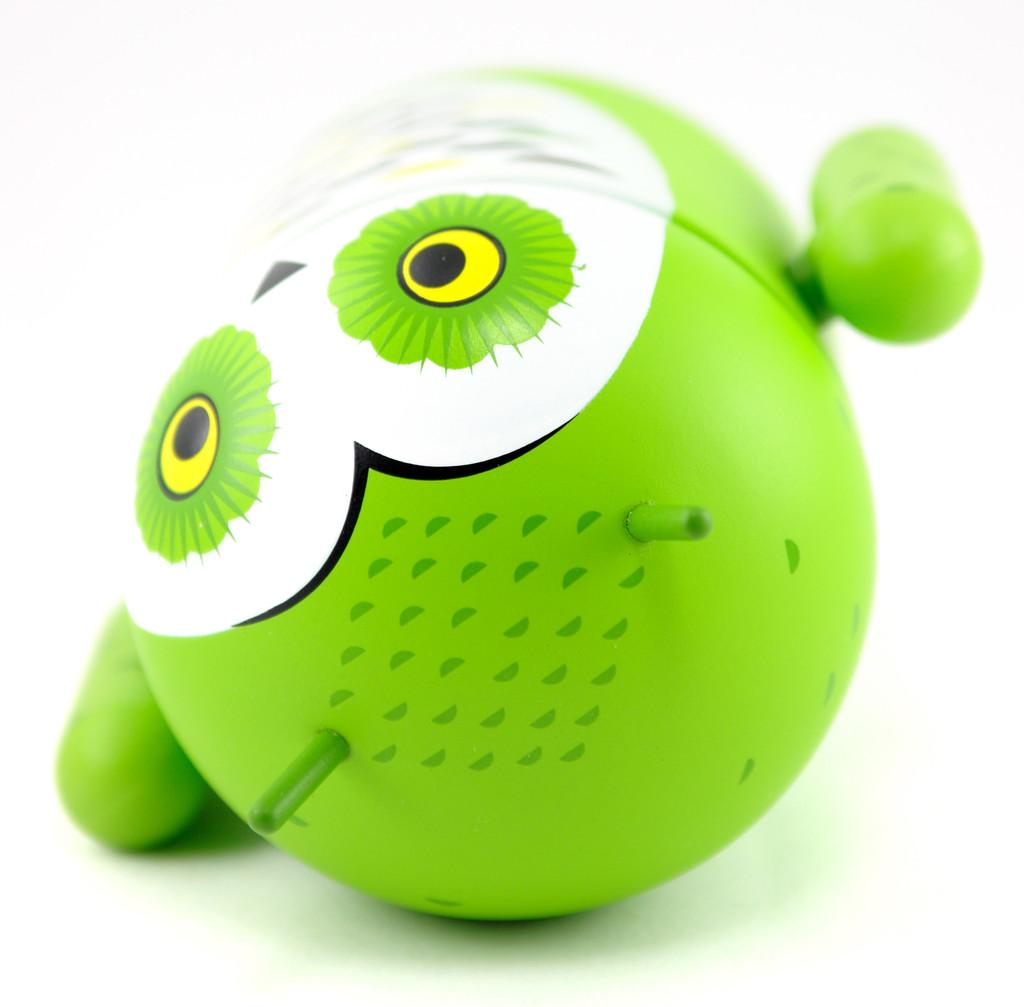What object in the image is designed for play? There is a toy in the image. How much sugar is in the toy in the image? There is no sugar present in the toy in the image, as it is a play object and not a food item. 